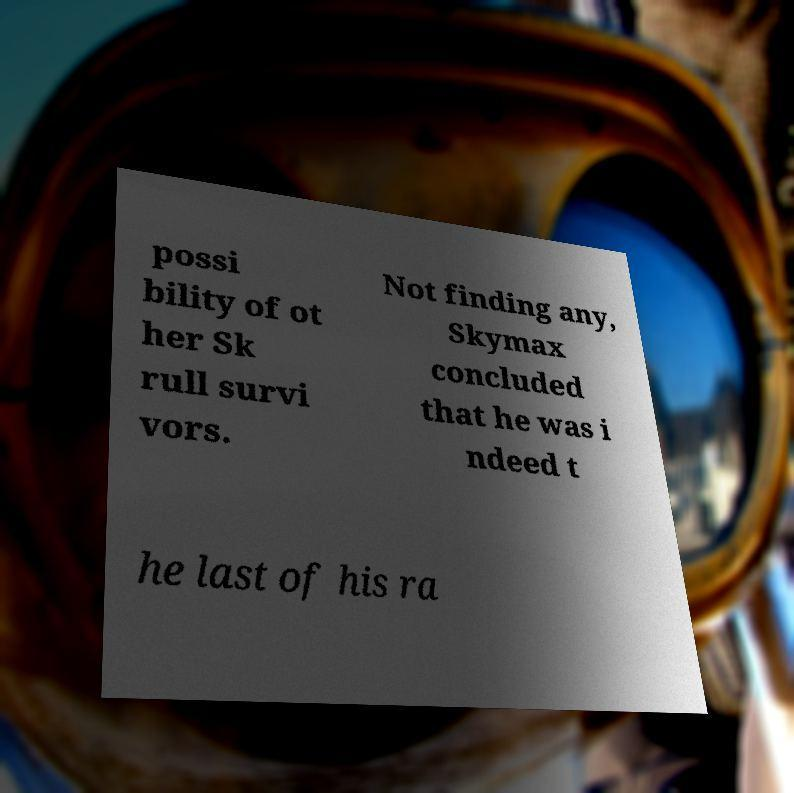I need the written content from this picture converted into text. Can you do that? possi bility of ot her Sk rull survi vors. Not finding any, Skymax concluded that he was i ndeed t he last of his ra 